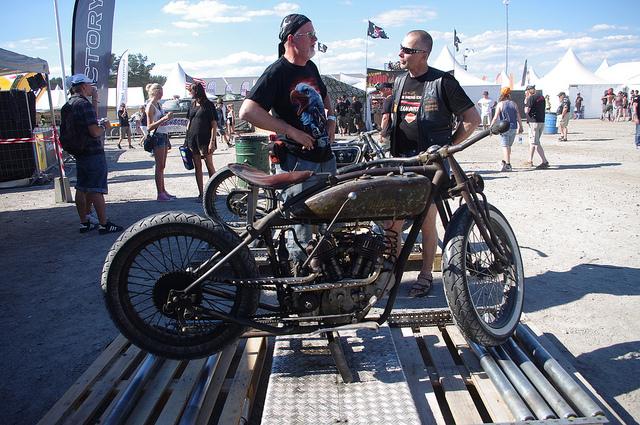What is the man on the right wearing on his face?
Quick response, please. Sunglasses. What is the weather like?
Concise answer only. Sunny. Does the bike look brand new?
Quick response, please. No. 